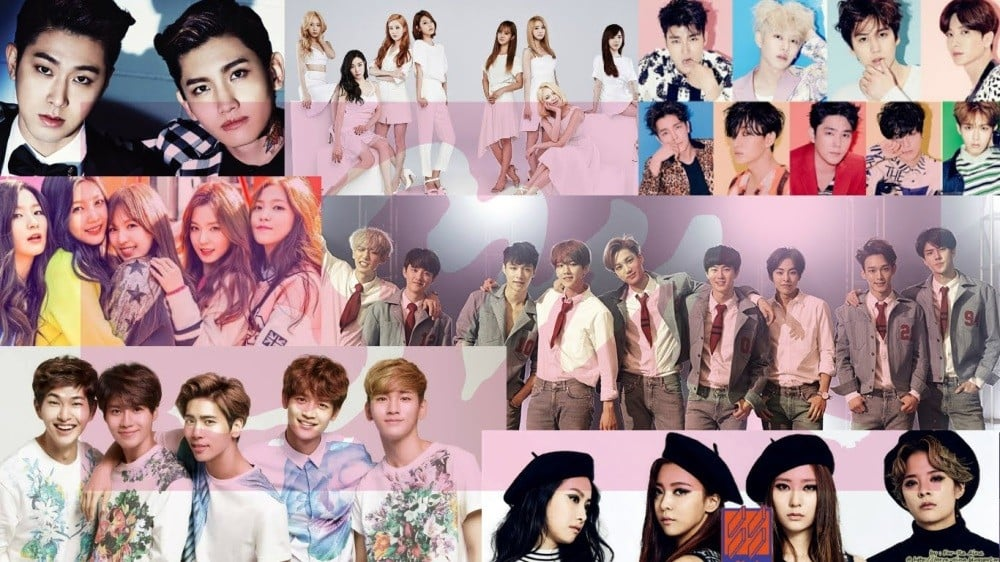What kind of impact do these styling choices have on the global audience of K-pop? The styling choices of K-pop groups play a significant role in shaping their global appeal. Bold and creative fashion statements often transcend cultural and linguistic barriers, allowing fans from diverse backgrounds to connect with the visual artistry and aspirational aspects of K-pop. The strategic use of fashion helps K-pop idols to stand out, sparking global fashion trends and influencing the styles of fans worldwide. These choices also support the branding of each group, making them recognizable and unforgettable in the minds of international audiences. Furthermore, the emphasis on coordinated group aesthetics fosters a strong sense of unity and identity, reinforcing the image of the group as a cohesive and well-rounded unit. This unified yet distinct visual presence helps to sustain the groups' popularity and influence on a global scale. 